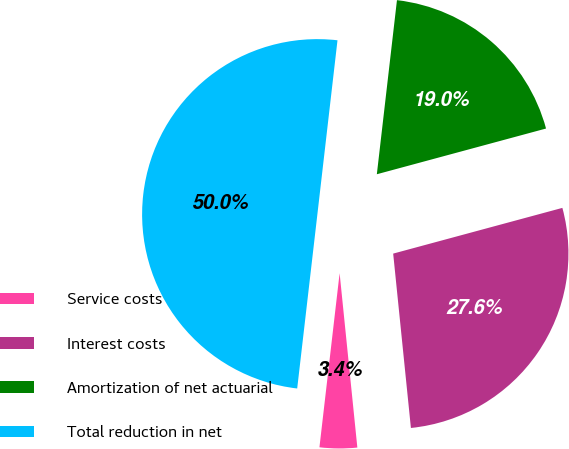Convert chart to OTSL. <chart><loc_0><loc_0><loc_500><loc_500><pie_chart><fcel>Service costs<fcel>Interest costs<fcel>Amortization of net actuarial<fcel>Total reduction in net<nl><fcel>3.45%<fcel>27.59%<fcel>18.97%<fcel>50.0%<nl></chart> 